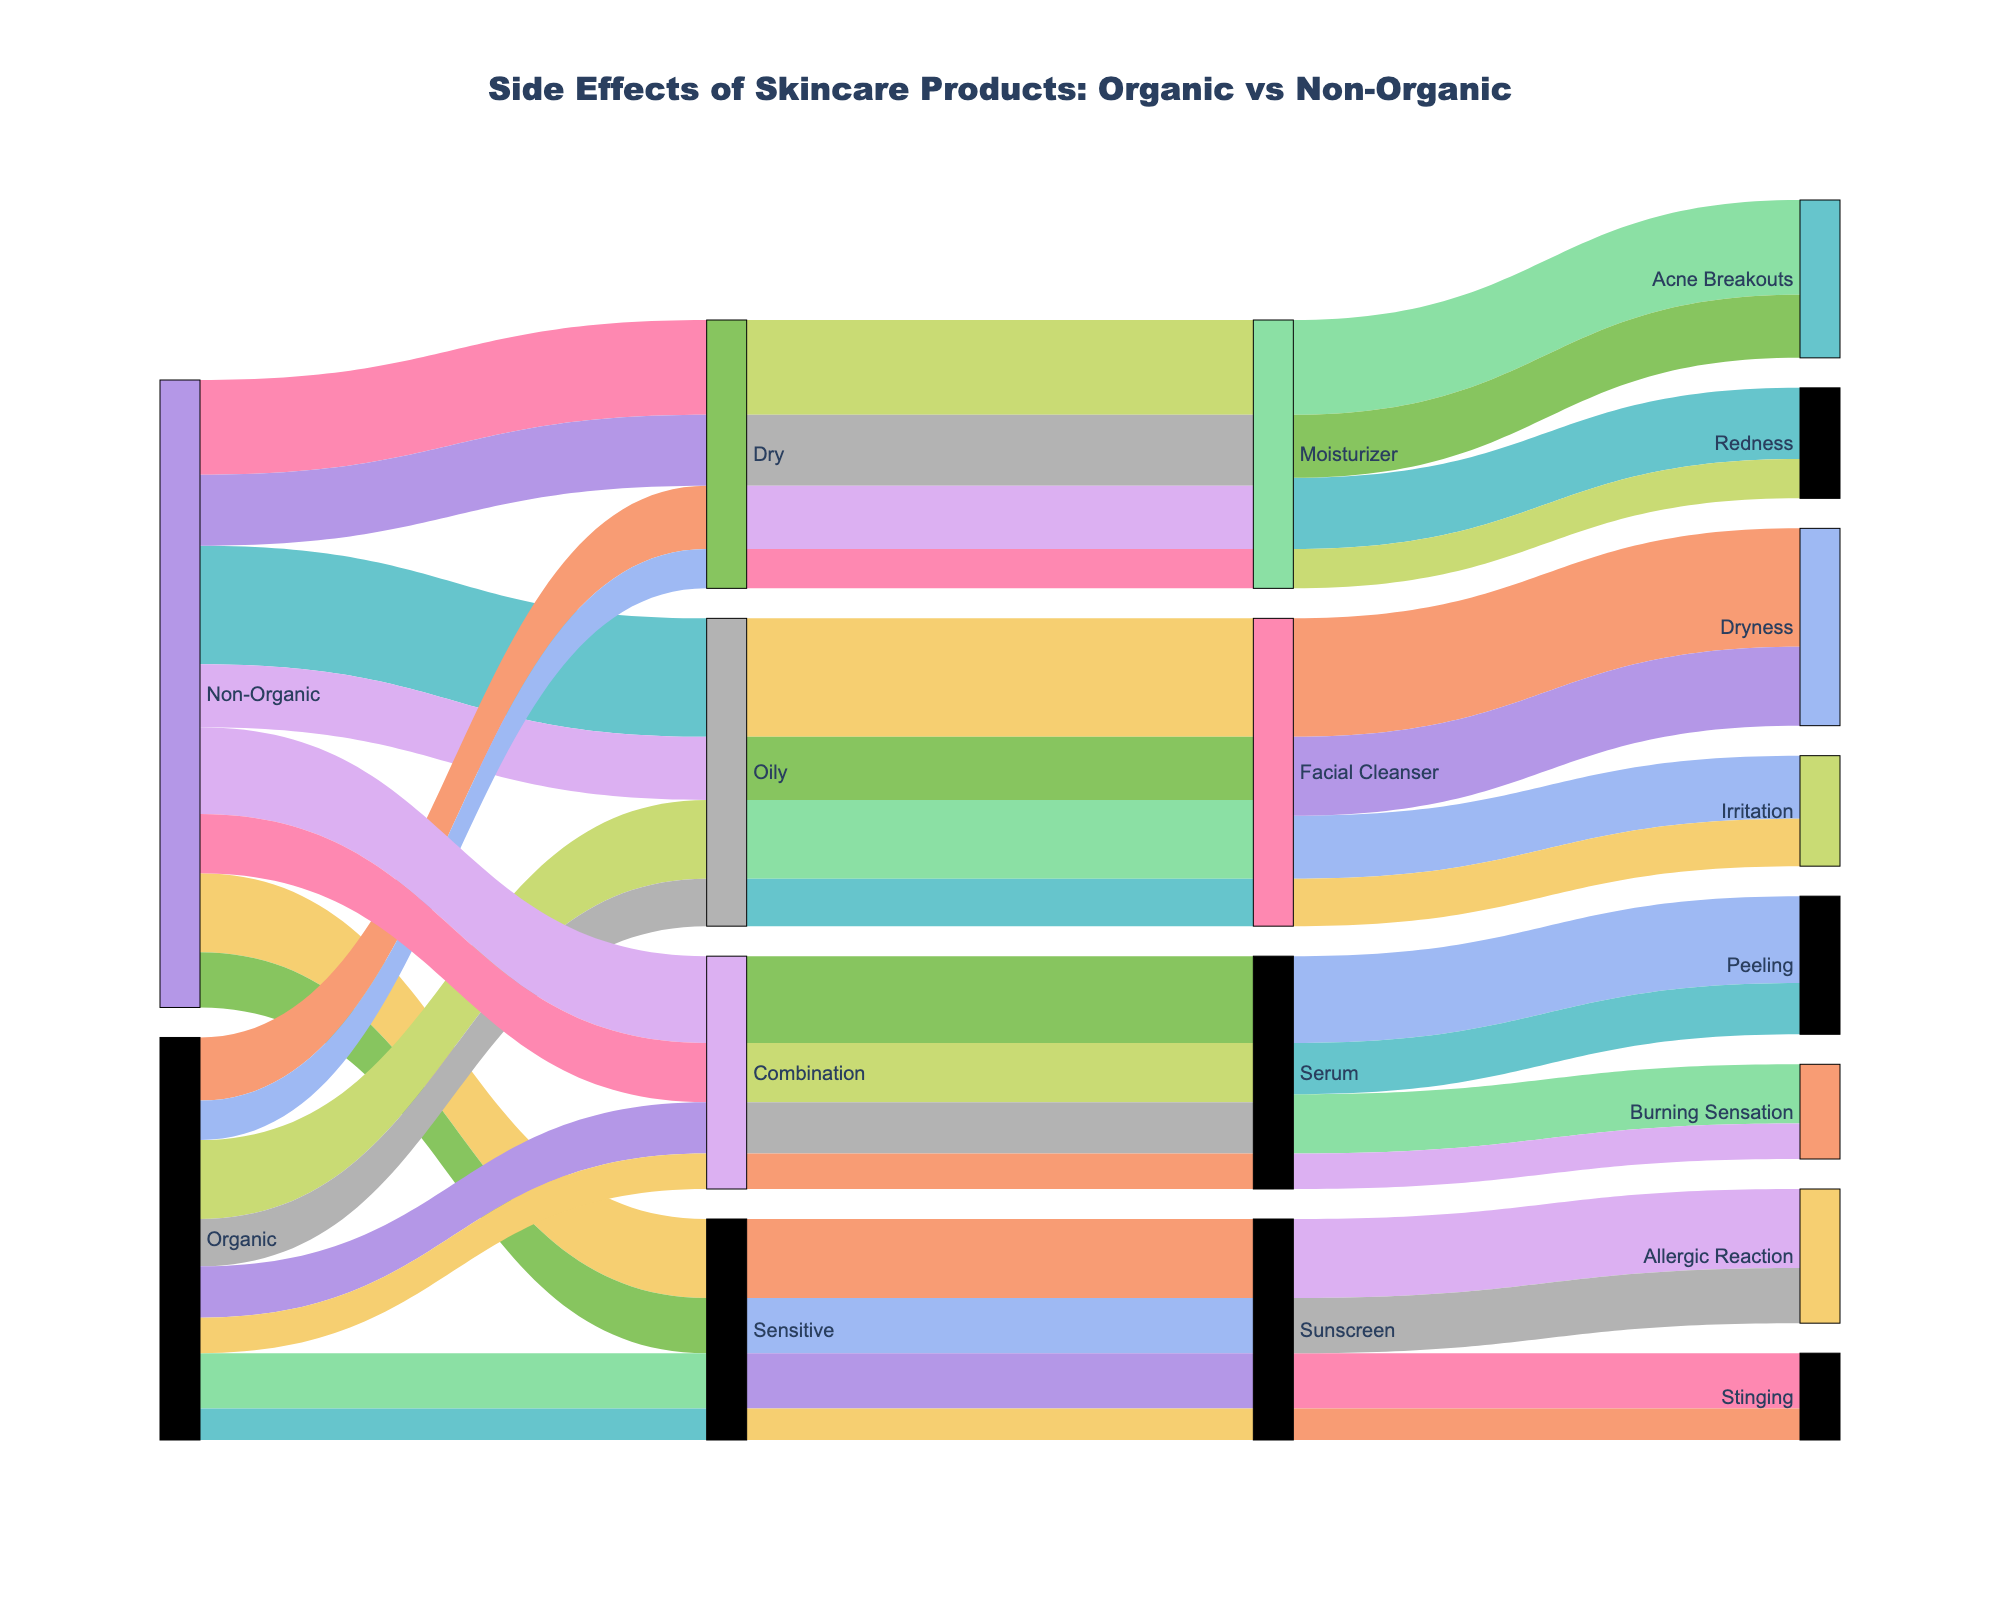How many side effects are reported for non-organic facial cleansers? To answer this, sum the counts of side effects under Non-Organic, Oily, Facial Cleanser. We have Dryness (150) and Irritation (80). So, total side effects = 150 + 80.
Answer: 230 Which product type has the most side effects reported for organic formulations? Compare the total counts of side effects for each product type under Organic. We have: Facial Cleanser (Dryness + Irritation = 100 + 60 = 160), Moisturizer (Acne Breakouts + Redness = 80 + 50 = 130), and Sunscreen (Allergic Reaction + Stinging = 70 + 40 = 110). The product type with the most side effects is Facial Cleanser with 160 side effects.
Answer: Facial Cleanser What is the total number of side effects reported for sensitive skin type? Sum all counts of side effects for both Organic and Non-Organic formulations under Sensitive. For Non-Organic: Allergic Reaction (100) + Stinging (70) = 170. For Organic: Allergic Reaction (70) + Stinging (40) = 110. Total side effects = 170 + 110.
Answer: 280 How does the count of allergic reactions compare between organic and non-organic sunscreens? Check the specific count for Allergic Reaction under Sunscreen for both Organic and Non-Organic. Non-Organic: 100 counts, Organic: 70 counts.
Answer: 100 vs 70 Which product type is associated with acne breakouts in dry skin when using organic products? Look under Organic, Dry, then check Product Type for side effect -> Acne Breakouts. It shows Moisturizer.
Answer: Moisturizer Are there more reports of stinging for organic or non-organic sunscreens for sensitive skin? Compare the count of Stinging for Sunscreen under Sensitive for both Organic (40) and Non-Organic (70). Non-Organic has more reports.
Answer: Non-Organic Identify one side effect that is more frequently reported in combination skin types when using non-organic products compared to organic products. Evaluate each side effect under Combination for both Organic and Non-Organic: Peeling (Non-Organic 110, Organic 65), Burning Sensation (Non-Organic 75, Organic 45). Peeling is more frequently reported in non-organic products.
Answer: Peeling What is the most common side effect reported for facial cleansers in organic products? Look at the side effects listed for Organic, Facial Cleanser. Dryness has 100 reports and Irritation has 60. Dryness is the most common.
Answer: Dryness Is redness more commonly reported for organic or non-organic moisturizers for dry skin? Compare the count of Redness under Moisturizer for Dry skin for both Organic (50) and Non-Organic (90). Non-Organic has more reports.
Answer: Non-Organic 